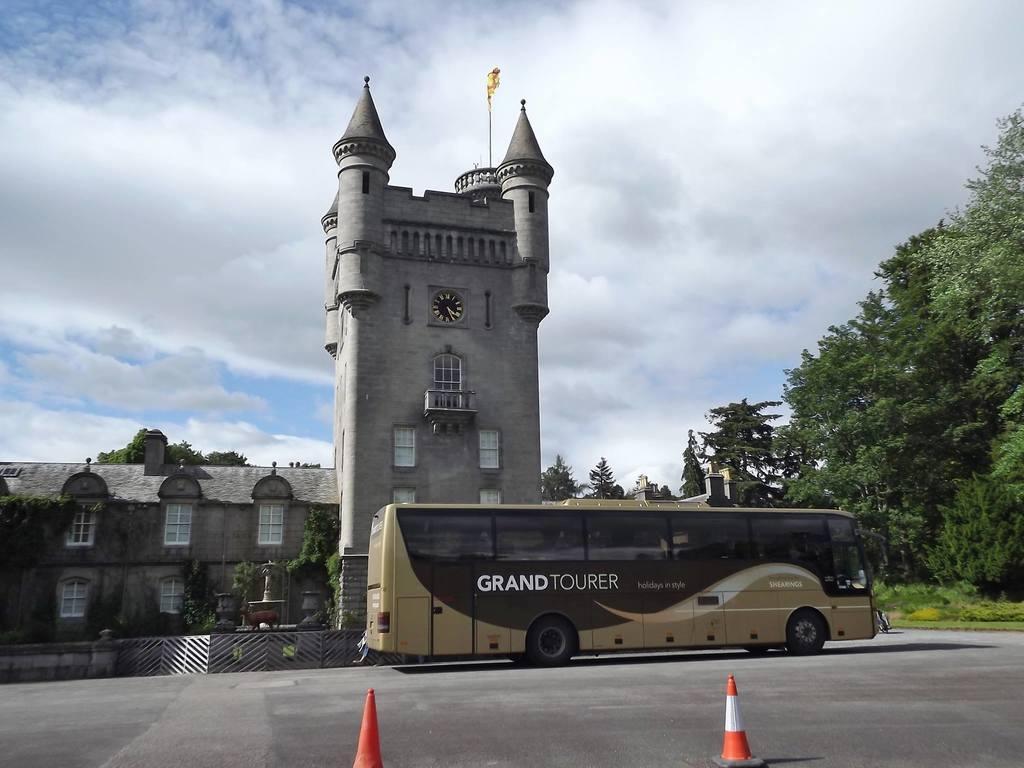How would you summarize this image in a sentence or two? In this image there a bus on a road, in the background there is a building, trees and the sky. 